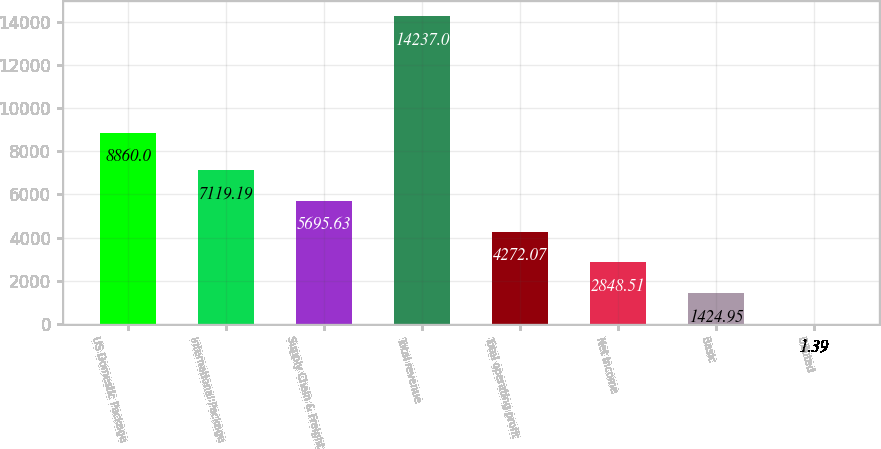<chart> <loc_0><loc_0><loc_500><loc_500><bar_chart><fcel>US Domestic Package<fcel>International Package<fcel>Supply Chain & Freight<fcel>Total revenue<fcel>Total operating profit<fcel>Net Income<fcel>Basic<fcel>Diluted<nl><fcel>8860<fcel>7119.19<fcel>5695.63<fcel>14237<fcel>4272.07<fcel>2848.51<fcel>1424.95<fcel>1.39<nl></chart> 